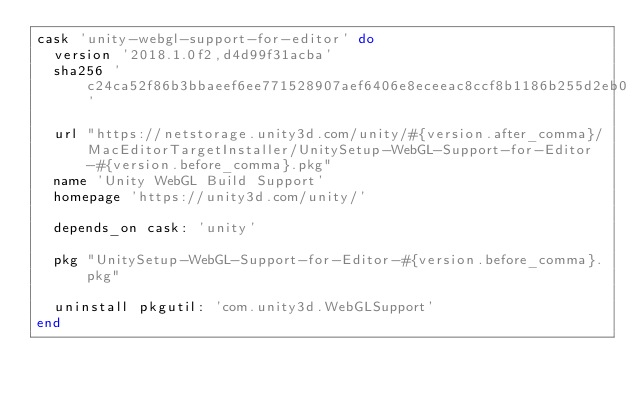<code> <loc_0><loc_0><loc_500><loc_500><_Ruby_>cask 'unity-webgl-support-for-editor' do
  version '2018.1.0f2,d4d99f31acba'
  sha256 'c24ca52f86b3bbaeef6ee771528907aef6406e8eceeac8ccf8b1186b255d2eb0'

  url "https://netstorage.unity3d.com/unity/#{version.after_comma}/MacEditorTargetInstaller/UnitySetup-WebGL-Support-for-Editor-#{version.before_comma}.pkg"
  name 'Unity WebGL Build Support'
  homepage 'https://unity3d.com/unity/'

  depends_on cask: 'unity'

  pkg "UnitySetup-WebGL-Support-for-Editor-#{version.before_comma}.pkg"

  uninstall pkgutil: 'com.unity3d.WebGLSupport'
end
</code> 